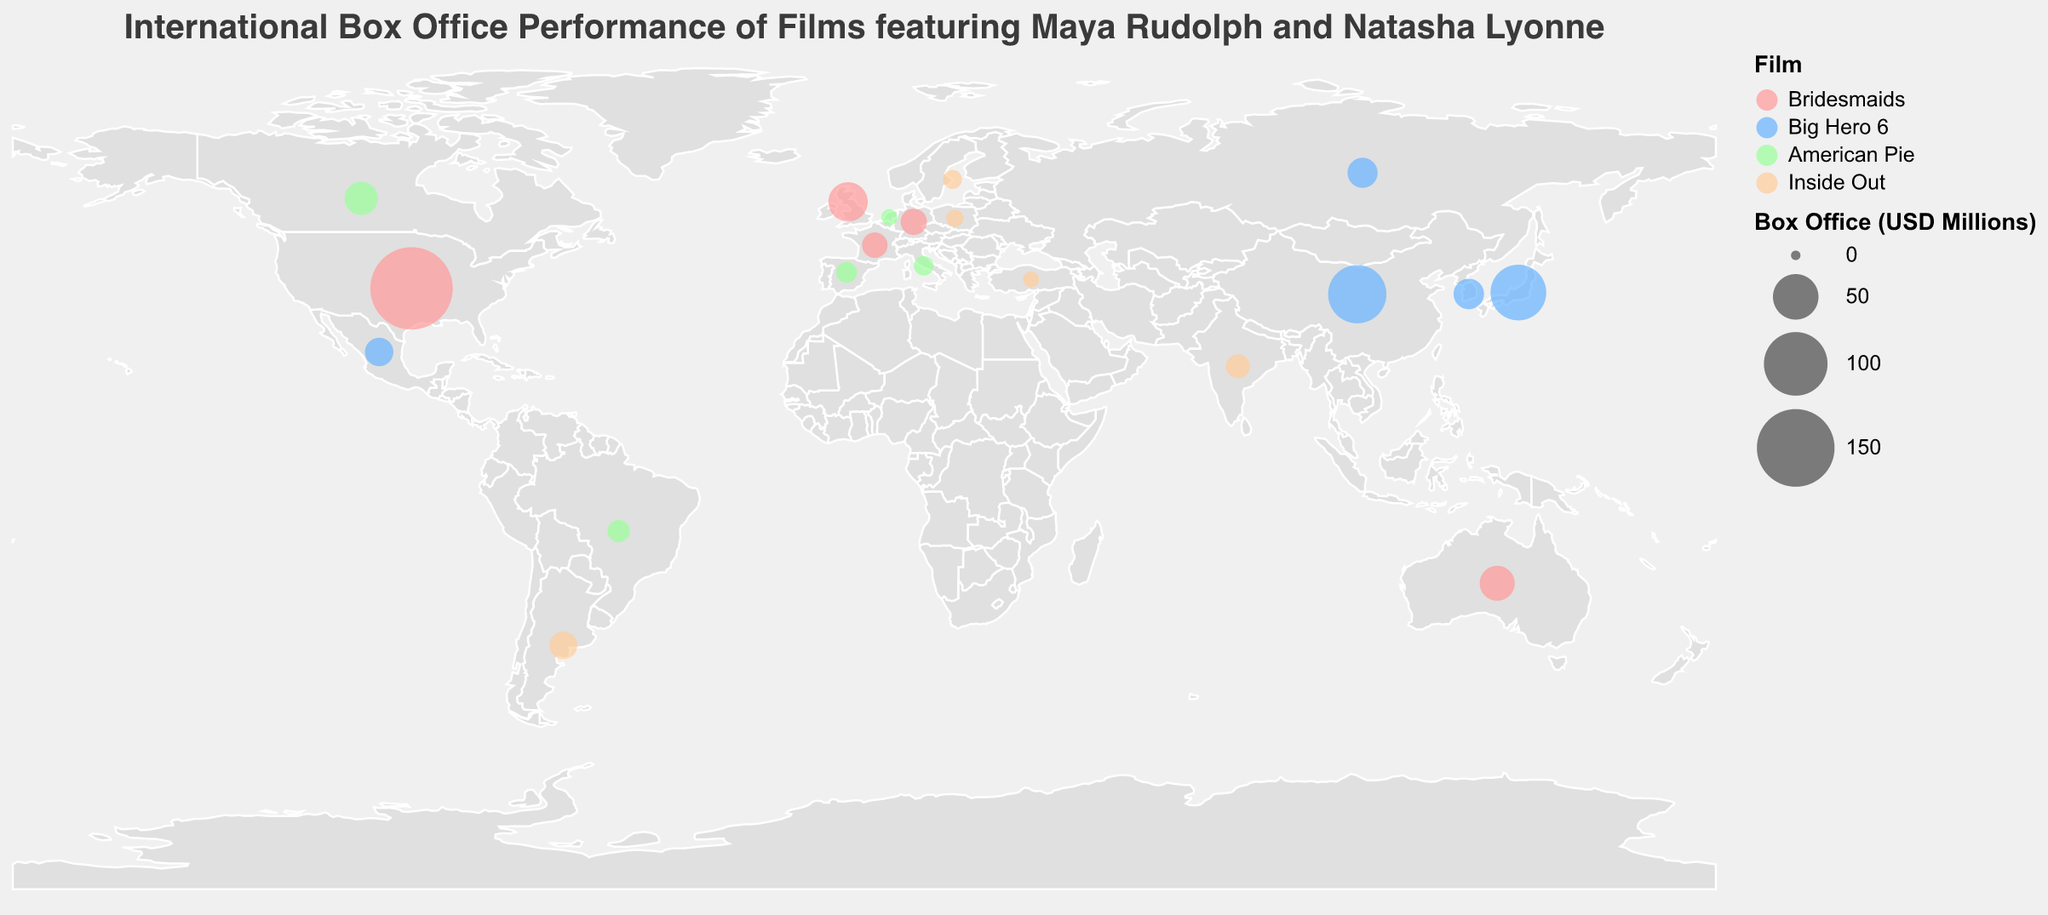What's the color associated with the film "Bridesmaids" on the map? The film "Bridesmaids" is indicated by a specific color in the legend of the map, which helps identify its data points.
Answer: Pink Which country had the highest box office performance for "Big Hero 6"? By examining the sizes of the circles and the associated labels for the film "Big Hero 6", you can see that China has the largest circle with a value of 83.5 million USD.
Answer: China How many countries are listed in total for the box office performance of films featuring Maya Rudolph and Natasha Lyonne? Count each unique country listed for different films provided in the data and represented on the map. This totals up to 20 countries.
Answer: 20 Which film has data points represented in the most countries? Compare the number of countries for each film by counting the distinct locations on the map. "Big Hero 6" appears in 5 countries, the most among all listed films.
Answer: Big Hero 6 What is the combined box office total for "American Pie" across all listed countries? Sum the box office amounts for each country showing "American Pie": 25.8 + 10.2 + 8.7 + 7.5 + 4.3 = 56.5 million USD.
Answer: 56.5 million USD How does the box office performance of "Inside Out" in India compare to Argentina? By checking the box office figures for these countries on the map, "Inside Out" earned 12.4 million USD in India and 17.3 million USD in Argentina. Therefore, Argentina outperformed India.
Answer: Argentina Which film and country combination had the lowest box office performance? Find the smallest circle on the map representing the least box office revenue. The film "Inside Out" in Turkey has the lowest recorded performance of 4.1 million USD.
Answer: Inside Out in Turkey What is the total box office revenue for "Bridesmaids" in Europe (considering United Kingdom, Germany, and France)? Sum the box office figures for European countries featuring "Bridesmaids": 36.8 + 15.3 + 14.2 = 66.3 million USD.
Answer: 66.3 million USD How does the performance of "Bridesmaids" in Australia compare to "American Pie" in Canada? By comparing the box office amounts, "Bridesmaids" in Australia had a revenue of 28.7 million USD, while "American Pie" in Canada earned 25.8 million USD. "Bridesmaids" outperformed in Australia.
Answer: Bridesmaids in Australia What is the average box office earnings of "Inside Out" across the listed countries? Calculate the average by summing the box office figures for "Inside Out" and dividing by the number of countries: (12.4 + 17.3 + 6.8 + 5.2 + 4.1) / 5 = 45.8 / 5 = 9.16 million USD.
Answer: 9.16 million USD 